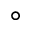Convert formula to latex. <formula><loc_0><loc_0><loc_500><loc_500>^ { \circ }</formula> 